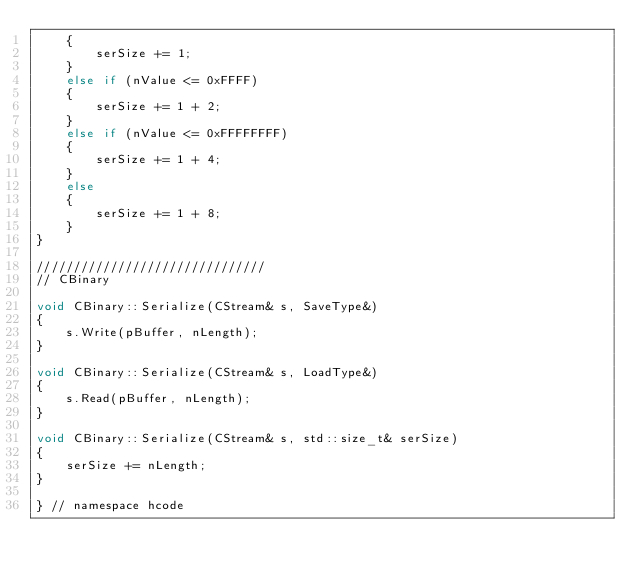Convert code to text. <code><loc_0><loc_0><loc_500><loc_500><_C++_>    {
        serSize += 1;
    }
    else if (nValue <= 0xFFFF)
    {
        serSize += 1 + 2;
    }
    else if (nValue <= 0xFFFFFFFF)
    {
        serSize += 1 + 4;
    }
    else
    {
        serSize += 1 + 8;
    }
}

///////////////////////////////
// CBinary

void CBinary::Serialize(CStream& s, SaveType&)
{
    s.Write(pBuffer, nLength);
}

void CBinary::Serialize(CStream& s, LoadType&)
{
    s.Read(pBuffer, nLength);
}

void CBinary::Serialize(CStream& s, std::size_t& serSize)
{
    serSize += nLength;
}

} // namespace hcode
</code> 